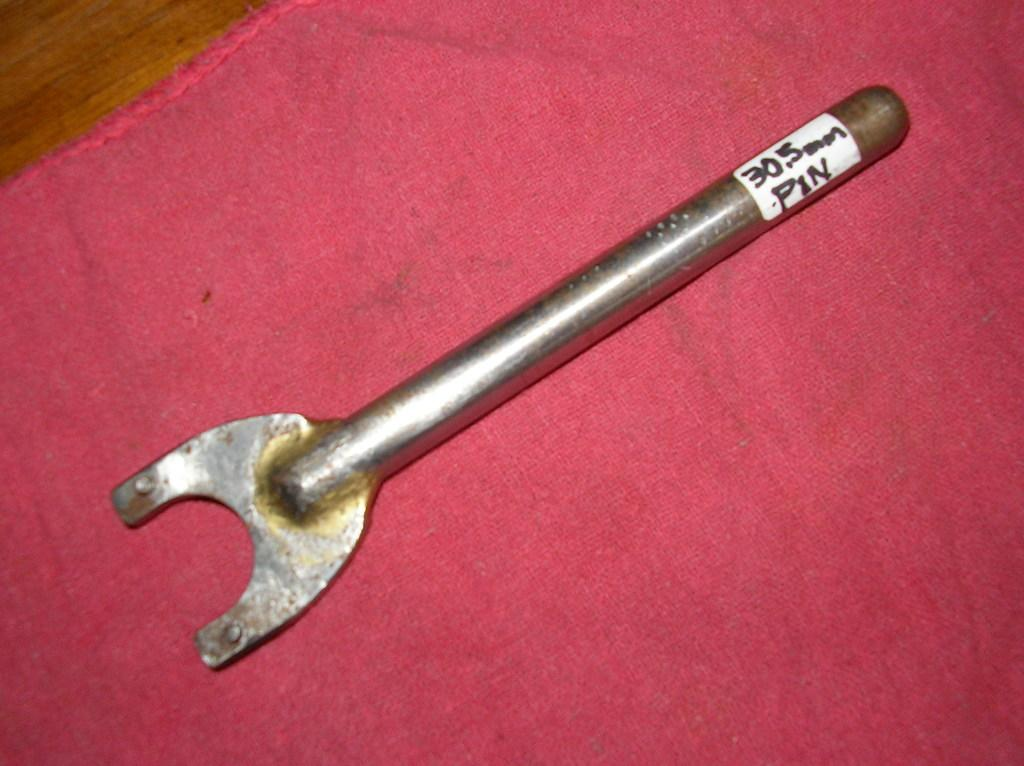What type of object is made of metal in the image? There is a metal tool in the image. What other item can be seen in the image besides the metal tool? There is a cloth in the image. Where is the cloth located in the image? The cloth is on a platform. What type of skate is being used to clean the metal tool in the image? There is no skate present in the image, and the metal tool is not being cleaned. 